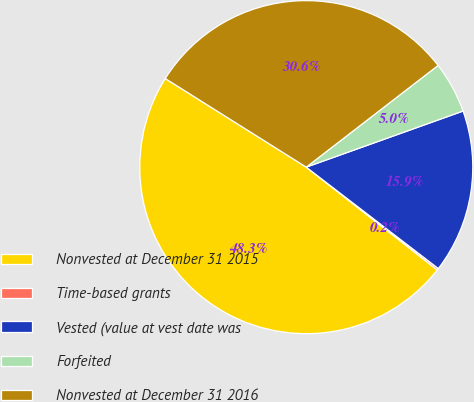Convert chart to OTSL. <chart><loc_0><loc_0><loc_500><loc_500><pie_chart><fcel>Nonvested at December 31 2015<fcel>Time-based grants<fcel>Vested (value at vest date was<fcel>Forfeited<fcel>Nonvested at December 31 2016<nl><fcel>48.34%<fcel>0.17%<fcel>15.89%<fcel>4.99%<fcel>30.61%<nl></chart> 